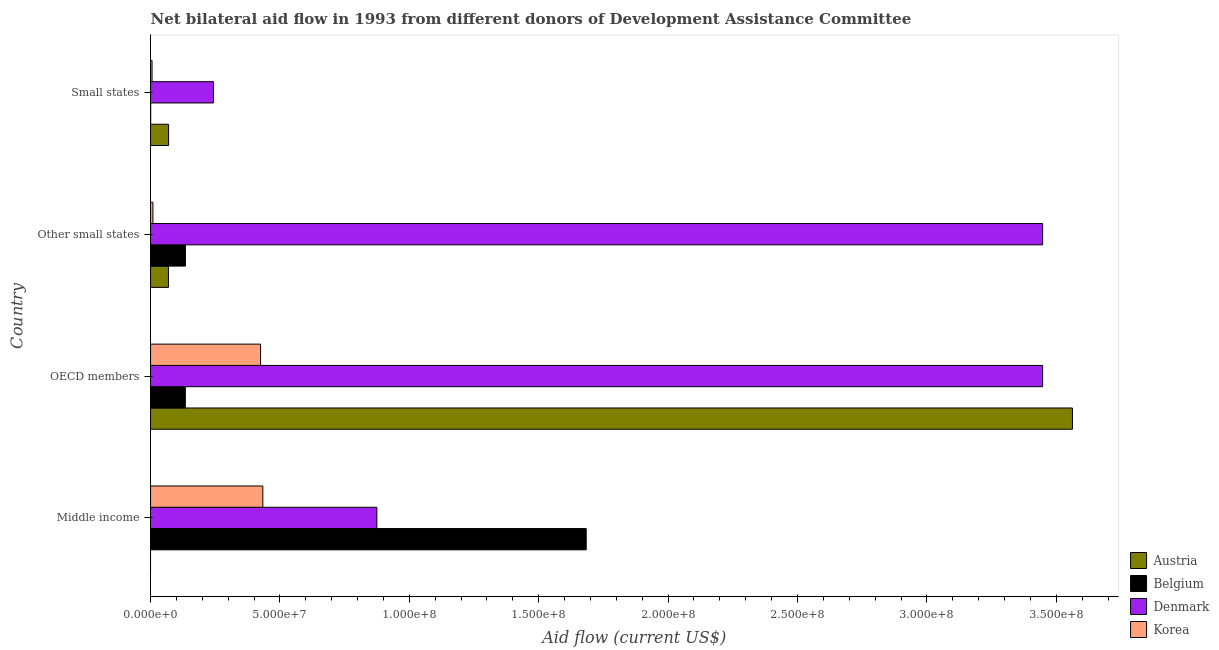How many different coloured bars are there?
Your answer should be very brief. 4. Are the number of bars per tick equal to the number of legend labels?
Your answer should be compact. No. Are the number of bars on each tick of the Y-axis equal?
Offer a very short reply. No. How many bars are there on the 1st tick from the bottom?
Make the answer very short. 3. What is the label of the 4th group of bars from the top?
Keep it short and to the point. Middle income. In how many cases, is the number of bars for a given country not equal to the number of legend labels?
Your answer should be very brief. 1. What is the amount of aid given by belgium in OECD members?
Provide a short and direct response. 1.34e+07. Across all countries, what is the maximum amount of aid given by denmark?
Ensure brevity in your answer.  3.45e+08. In which country was the amount of aid given by denmark maximum?
Keep it short and to the point. OECD members. What is the total amount of aid given by korea in the graph?
Offer a terse response. 8.74e+07. What is the difference between the amount of aid given by denmark in Middle income and that in OECD members?
Make the answer very short. -2.57e+08. What is the difference between the amount of aid given by korea in Middle income and the amount of aid given by belgium in OECD members?
Offer a very short reply. 3.00e+07. What is the average amount of aid given by denmark per country?
Offer a terse response. 2.00e+08. What is the difference between the amount of aid given by korea and amount of aid given by denmark in Middle income?
Your answer should be compact. -4.41e+07. In how many countries, is the amount of aid given by korea greater than 200000000 US$?
Give a very brief answer. 0. What is the ratio of the amount of aid given by austria in OECD members to that in Other small states?
Your answer should be very brief. 51.48. What is the difference between the highest and the second highest amount of aid given by belgium?
Offer a terse response. 1.55e+08. What is the difference between the highest and the lowest amount of aid given by austria?
Offer a very short reply. 3.56e+08. Is the sum of the amount of aid given by belgium in Other small states and Small states greater than the maximum amount of aid given by denmark across all countries?
Ensure brevity in your answer.  No. How many legend labels are there?
Offer a terse response. 4. What is the title of the graph?
Provide a succinct answer. Net bilateral aid flow in 1993 from different donors of Development Assistance Committee. Does "Custom duties" appear as one of the legend labels in the graph?
Keep it short and to the point. No. What is the label or title of the Y-axis?
Keep it short and to the point. Country. What is the Aid flow (current US$) of Austria in Middle income?
Offer a terse response. 0. What is the Aid flow (current US$) in Belgium in Middle income?
Offer a terse response. 1.68e+08. What is the Aid flow (current US$) in Denmark in Middle income?
Ensure brevity in your answer.  8.75e+07. What is the Aid flow (current US$) of Korea in Middle income?
Provide a succinct answer. 4.34e+07. What is the Aid flow (current US$) of Austria in OECD members?
Ensure brevity in your answer.  3.56e+08. What is the Aid flow (current US$) in Belgium in OECD members?
Your response must be concise. 1.34e+07. What is the Aid flow (current US$) in Denmark in OECD members?
Ensure brevity in your answer.  3.45e+08. What is the Aid flow (current US$) of Korea in OECD members?
Make the answer very short. 4.25e+07. What is the Aid flow (current US$) of Austria in Other small states?
Offer a terse response. 6.92e+06. What is the Aid flow (current US$) in Belgium in Other small states?
Provide a succinct answer. 1.35e+07. What is the Aid flow (current US$) in Denmark in Other small states?
Your answer should be compact. 3.45e+08. What is the Aid flow (current US$) of Korea in Other small states?
Provide a succinct answer. 9.20e+05. What is the Aid flow (current US$) in Austria in Small states?
Offer a very short reply. 6.97e+06. What is the Aid flow (current US$) of Denmark in Small states?
Your answer should be very brief. 2.43e+07. What is the Aid flow (current US$) of Korea in Small states?
Make the answer very short. 5.80e+05. Across all countries, what is the maximum Aid flow (current US$) of Austria?
Your answer should be compact. 3.56e+08. Across all countries, what is the maximum Aid flow (current US$) in Belgium?
Offer a very short reply. 1.68e+08. Across all countries, what is the maximum Aid flow (current US$) in Denmark?
Keep it short and to the point. 3.45e+08. Across all countries, what is the maximum Aid flow (current US$) of Korea?
Ensure brevity in your answer.  4.34e+07. Across all countries, what is the minimum Aid flow (current US$) in Belgium?
Provide a succinct answer. 5.00e+04. Across all countries, what is the minimum Aid flow (current US$) in Denmark?
Provide a short and direct response. 2.43e+07. Across all countries, what is the minimum Aid flow (current US$) in Korea?
Give a very brief answer. 5.80e+05. What is the total Aid flow (current US$) in Austria in the graph?
Your answer should be compact. 3.70e+08. What is the total Aid flow (current US$) in Belgium in the graph?
Your answer should be very brief. 1.95e+08. What is the total Aid flow (current US$) of Denmark in the graph?
Keep it short and to the point. 8.01e+08. What is the total Aid flow (current US$) in Korea in the graph?
Offer a very short reply. 8.74e+07. What is the difference between the Aid flow (current US$) of Belgium in Middle income and that in OECD members?
Provide a short and direct response. 1.55e+08. What is the difference between the Aid flow (current US$) in Denmark in Middle income and that in OECD members?
Offer a very short reply. -2.57e+08. What is the difference between the Aid flow (current US$) in Korea in Middle income and that in OECD members?
Give a very brief answer. 8.80e+05. What is the difference between the Aid flow (current US$) in Belgium in Middle income and that in Other small states?
Ensure brevity in your answer.  1.55e+08. What is the difference between the Aid flow (current US$) of Denmark in Middle income and that in Other small states?
Your answer should be compact. -2.57e+08. What is the difference between the Aid flow (current US$) of Korea in Middle income and that in Other small states?
Your response must be concise. 4.25e+07. What is the difference between the Aid flow (current US$) of Belgium in Middle income and that in Small states?
Ensure brevity in your answer.  1.68e+08. What is the difference between the Aid flow (current US$) of Denmark in Middle income and that in Small states?
Offer a very short reply. 6.32e+07. What is the difference between the Aid flow (current US$) of Korea in Middle income and that in Small states?
Make the answer very short. 4.28e+07. What is the difference between the Aid flow (current US$) of Austria in OECD members and that in Other small states?
Offer a terse response. 3.49e+08. What is the difference between the Aid flow (current US$) in Denmark in OECD members and that in Other small states?
Your response must be concise. 0. What is the difference between the Aid flow (current US$) in Korea in OECD members and that in Other small states?
Make the answer very short. 4.16e+07. What is the difference between the Aid flow (current US$) in Austria in OECD members and that in Small states?
Provide a succinct answer. 3.49e+08. What is the difference between the Aid flow (current US$) in Belgium in OECD members and that in Small states?
Make the answer very short. 1.34e+07. What is the difference between the Aid flow (current US$) of Denmark in OECD members and that in Small states?
Ensure brevity in your answer.  3.20e+08. What is the difference between the Aid flow (current US$) in Korea in OECD members and that in Small states?
Give a very brief answer. 4.19e+07. What is the difference between the Aid flow (current US$) in Austria in Other small states and that in Small states?
Ensure brevity in your answer.  -5.00e+04. What is the difference between the Aid flow (current US$) of Belgium in Other small states and that in Small states?
Your answer should be compact. 1.34e+07. What is the difference between the Aid flow (current US$) of Denmark in Other small states and that in Small states?
Make the answer very short. 3.20e+08. What is the difference between the Aid flow (current US$) in Korea in Other small states and that in Small states?
Offer a very short reply. 3.40e+05. What is the difference between the Aid flow (current US$) of Belgium in Middle income and the Aid flow (current US$) of Denmark in OECD members?
Give a very brief answer. -1.76e+08. What is the difference between the Aid flow (current US$) of Belgium in Middle income and the Aid flow (current US$) of Korea in OECD members?
Provide a short and direct response. 1.26e+08. What is the difference between the Aid flow (current US$) in Denmark in Middle income and the Aid flow (current US$) in Korea in OECD members?
Keep it short and to the point. 4.49e+07. What is the difference between the Aid flow (current US$) in Belgium in Middle income and the Aid flow (current US$) in Denmark in Other small states?
Ensure brevity in your answer.  -1.76e+08. What is the difference between the Aid flow (current US$) in Belgium in Middle income and the Aid flow (current US$) in Korea in Other small states?
Provide a short and direct response. 1.67e+08. What is the difference between the Aid flow (current US$) of Denmark in Middle income and the Aid flow (current US$) of Korea in Other small states?
Provide a short and direct response. 8.65e+07. What is the difference between the Aid flow (current US$) in Belgium in Middle income and the Aid flow (current US$) in Denmark in Small states?
Keep it short and to the point. 1.44e+08. What is the difference between the Aid flow (current US$) in Belgium in Middle income and the Aid flow (current US$) in Korea in Small states?
Give a very brief answer. 1.68e+08. What is the difference between the Aid flow (current US$) in Denmark in Middle income and the Aid flow (current US$) in Korea in Small states?
Provide a succinct answer. 8.69e+07. What is the difference between the Aid flow (current US$) in Austria in OECD members and the Aid flow (current US$) in Belgium in Other small states?
Make the answer very short. 3.43e+08. What is the difference between the Aid flow (current US$) of Austria in OECD members and the Aid flow (current US$) of Denmark in Other small states?
Your answer should be compact. 1.15e+07. What is the difference between the Aid flow (current US$) in Austria in OECD members and the Aid flow (current US$) in Korea in Other small states?
Your answer should be compact. 3.55e+08. What is the difference between the Aid flow (current US$) in Belgium in OECD members and the Aid flow (current US$) in Denmark in Other small states?
Your answer should be very brief. -3.31e+08. What is the difference between the Aid flow (current US$) of Belgium in OECD members and the Aid flow (current US$) of Korea in Other small states?
Give a very brief answer. 1.25e+07. What is the difference between the Aid flow (current US$) in Denmark in OECD members and the Aid flow (current US$) in Korea in Other small states?
Give a very brief answer. 3.44e+08. What is the difference between the Aid flow (current US$) of Austria in OECD members and the Aid flow (current US$) of Belgium in Small states?
Your response must be concise. 3.56e+08. What is the difference between the Aid flow (current US$) of Austria in OECD members and the Aid flow (current US$) of Denmark in Small states?
Offer a terse response. 3.32e+08. What is the difference between the Aid flow (current US$) in Austria in OECD members and the Aid flow (current US$) in Korea in Small states?
Offer a terse response. 3.56e+08. What is the difference between the Aid flow (current US$) of Belgium in OECD members and the Aid flow (current US$) of Denmark in Small states?
Your answer should be very brief. -1.09e+07. What is the difference between the Aid flow (current US$) of Belgium in OECD members and the Aid flow (current US$) of Korea in Small states?
Your answer should be very brief. 1.29e+07. What is the difference between the Aid flow (current US$) in Denmark in OECD members and the Aid flow (current US$) in Korea in Small states?
Make the answer very short. 3.44e+08. What is the difference between the Aid flow (current US$) of Austria in Other small states and the Aid flow (current US$) of Belgium in Small states?
Your answer should be compact. 6.87e+06. What is the difference between the Aid flow (current US$) of Austria in Other small states and the Aid flow (current US$) of Denmark in Small states?
Provide a succinct answer. -1.74e+07. What is the difference between the Aid flow (current US$) in Austria in Other small states and the Aid flow (current US$) in Korea in Small states?
Offer a very short reply. 6.34e+06. What is the difference between the Aid flow (current US$) of Belgium in Other small states and the Aid flow (current US$) of Denmark in Small states?
Your response must be concise. -1.08e+07. What is the difference between the Aid flow (current US$) in Belgium in Other small states and the Aid flow (current US$) in Korea in Small states?
Provide a short and direct response. 1.29e+07. What is the difference between the Aid flow (current US$) in Denmark in Other small states and the Aid flow (current US$) in Korea in Small states?
Give a very brief answer. 3.44e+08. What is the average Aid flow (current US$) of Austria per country?
Offer a very short reply. 9.25e+07. What is the average Aid flow (current US$) of Belgium per country?
Provide a succinct answer. 4.88e+07. What is the average Aid flow (current US$) in Denmark per country?
Ensure brevity in your answer.  2.00e+08. What is the average Aid flow (current US$) of Korea per country?
Provide a succinct answer. 2.19e+07. What is the difference between the Aid flow (current US$) in Belgium and Aid flow (current US$) in Denmark in Middle income?
Offer a terse response. 8.09e+07. What is the difference between the Aid flow (current US$) of Belgium and Aid flow (current US$) of Korea in Middle income?
Provide a succinct answer. 1.25e+08. What is the difference between the Aid flow (current US$) in Denmark and Aid flow (current US$) in Korea in Middle income?
Offer a very short reply. 4.41e+07. What is the difference between the Aid flow (current US$) of Austria and Aid flow (current US$) of Belgium in OECD members?
Your answer should be very brief. 3.43e+08. What is the difference between the Aid flow (current US$) in Austria and Aid flow (current US$) in Denmark in OECD members?
Provide a succinct answer. 1.15e+07. What is the difference between the Aid flow (current US$) of Austria and Aid flow (current US$) of Korea in OECD members?
Offer a very short reply. 3.14e+08. What is the difference between the Aid flow (current US$) of Belgium and Aid flow (current US$) of Denmark in OECD members?
Make the answer very short. -3.31e+08. What is the difference between the Aid flow (current US$) of Belgium and Aid flow (current US$) of Korea in OECD members?
Provide a succinct answer. -2.91e+07. What is the difference between the Aid flow (current US$) in Denmark and Aid flow (current US$) in Korea in OECD members?
Give a very brief answer. 3.02e+08. What is the difference between the Aid flow (current US$) in Austria and Aid flow (current US$) in Belgium in Other small states?
Ensure brevity in your answer.  -6.56e+06. What is the difference between the Aid flow (current US$) in Austria and Aid flow (current US$) in Denmark in Other small states?
Keep it short and to the point. -3.38e+08. What is the difference between the Aid flow (current US$) of Belgium and Aid flow (current US$) of Denmark in Other small states?
Offer a very short reply. -3.31e+08. What is the difference between the Aid flow (current US$) of Belgium and Aid flow (current US$) of Korea in Other small states?
Your answer should be very brief. 1.26e+07. What is the difference between the Aid flow (current US$) in Denmark and Aid flow (current US$) in Korea in Other small states?
Offer a very short reply. 3.44e+08. What is the difference between the Aid flow (current US$) of Austria and Aid flow (current US$) of Belgium in Small states?
Your answer should be very brief. 6.92e+06. What is the difference between the Aid flow (current US$) of Austria and Aid flow (current US$) of Denmark in Small states?
Your answer should be very brief. -1.73e+07. What is the difference between the Aid flow (current US$) of Austria and Aid flow (current US$) of Korea in Small states?
Offer a very short reply. 6.39e+06. What is the difference between the Aid flow (current US$) in Belgium and Aid flow (current US$) in Denmark in Small states?
Your answer should be very brief. -2.43e+07. What is the difference between the Aid flow (current US$) of Belgium and Aid flow (current US$) of Korea in Small states?
Your answer should be compact. -5.30e+05. What is the difference between the Aid flow (current US$) of Denmark and Aid flow (current US$) of Korea in Small states?
Provide a succinct answer. 2.37e+07. What is the ratio of the Aid flow (current US$) in Belgium in Middle income to that in OECD members?
Provide a succinct answer. 12.52. What is the ratio of the Aid flow (current US$) of Denmark in Middle income to that in OECD members?
Make the answer very short. 0.25. What is the ratio of the Aid flow (current US$) in Korea in Middle income to that in OECD members?
Ensure brevity in your answer.  1.02. What is the ratio of the Aid flow (current US$) in Belgium in Middle income to that in Other small states?
Make the answer very short. 12.49. What is the ratio of the Aid flow (current US$) of Denmark in Middle income to that in Other small states?
Make the answer very short. 0.25. What is the ratio of the Aid flow (current US$) in Korea in Middle income to that in Other small states?
Give a very brief answer. 47.17. What is the ratio of the Aid flow (current US$) of Belgium in Middle income to that in Small states?
Your response must be concise. 3367.2. What is the ratio of the Aid flow (current US$) in Denmark in Middle income to that in Small states?
Give a very brief answer. 3.6. What is the ratio of the Aid flow (current US$) in Korea in Middle income to that in Small states?
Provide a succinct answer. 74.83. What is the ratio of the Aid flow (current US$) in Austria in OECD members to that in Other small states?
Your answer should be compact. 51.48. What is the ratio of the Aid flow (current US$) in Belgium in OECD members to that in Other small states?
Give a very brief answer. 1. What is the ratio of the Aid flow (current US$) in Denmark in OECD members to that in Other small states?
Your response must be concise. 1. What is the ratio of the Aid flow (current US$) in Korea in OECD members to that in Other small states?
Your response must be concise. 46.22. What is the ratio of the Aid flow (current US$) in Austria in OECD members to that in Small states?
Provide a short and direct response. 51.11. What is the ratio of the Aid flow (current US$) in Belgium in OECD members to that in Small states?
Make the answer very short. 269. What is the ratio of the Aid flow (current US$) in Denmark in OECD members to that in Small states?
Provide a short and direct response. 14.18. What is the ratio of the Aid flow (current US$) in Korea in OECD members to that in Small states?
Provide a succinct answer. 73.31. What is the ratio of the Aid flow (current US$) in Austria in Other small states to that in Small states?
Your answer should be very brief. 0.99. What is the ratio of the Aid flow (current US$) in Belgium in Other small states to that in Small states?
Offer a terse response. 269.6. What is the ratio of the Aid flow (current US$) in Denmark in Other small states to that in Small states?
Your answer should be compact. 14.18. What is the ratio of the Aid flow (current US$) in Korea in Other small states to that in Small states?
Your answer should be very brief. 1.59. What is the difference between the highest and the second highest Aid flow (current US$) of Austria?
Make the answer very short. 3.49e+08. What is the difference between the highest and the second highest Aid flow (current US$) in Belgium?
Provide a short and direct response. 1.55e+08. What is the difference between the highest and the second highest Aid flow (current US$) in Denmark?
Offer a very short reply. 0. What is the difference between the highest and the second highest Aid flow (current US$) of Korea?
Your response must be concise. 8.80e+05. What is the difference between the highest and the lowest Aid flow (current US$) in Austria?
Provide a short and direct response. 3.56e+08. What is the difference between the highest and the lowest Aid flow (current US$) of Belgium?
Make the answer very short. 1.68e+08. What is the difference between the highest and the lowest Aid flow (current US$) of Denmark?
Provide a succinct answer. 3.20e+08. What is the difference between the highest and the lowest Aid flow (current US$) in Korea?
Your answer should be very brief. 4.28e+07. 